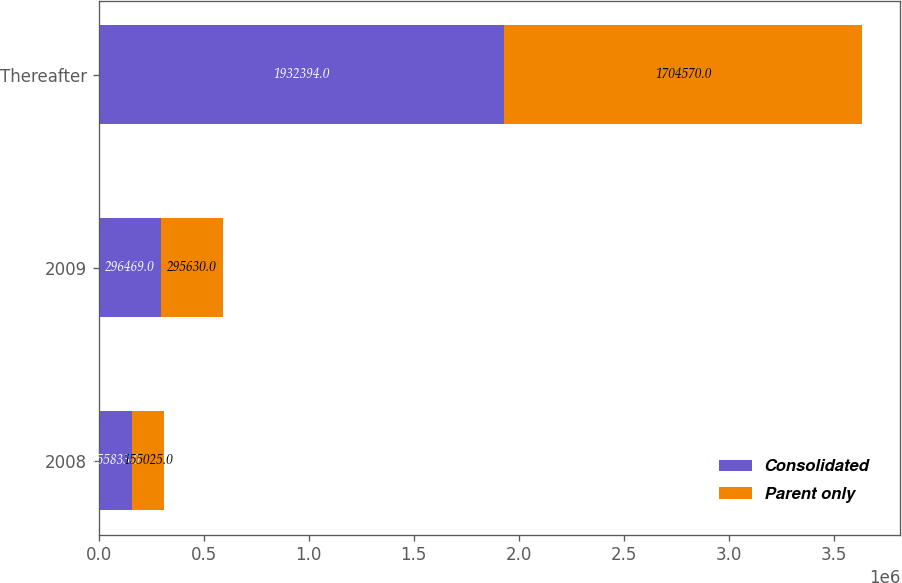<chart> <loc_0><loc_0><loc_500><loc_500><stacked_bar_chart><ecel><fcel>2008<fcel>2009<fcel>Thereafter<nl><fcel>Consolidated<fcel>155833<fcel>296469<fcel>1.93239e+06<nl><fcel>Parent only<fcel>155025<fcel>295630<fcel>1.70457e+06<nl></chart> 